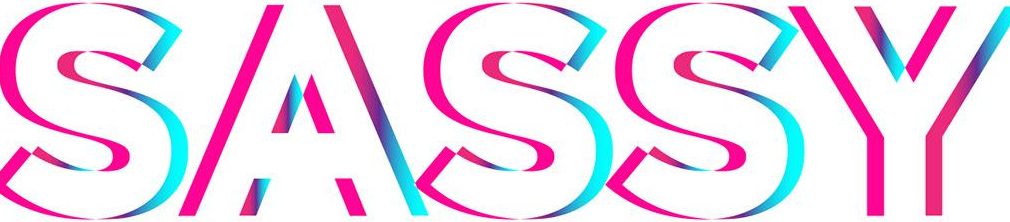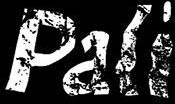What text is displayed in these images sequentially, separated by a semicolon? SASSY; Pali 